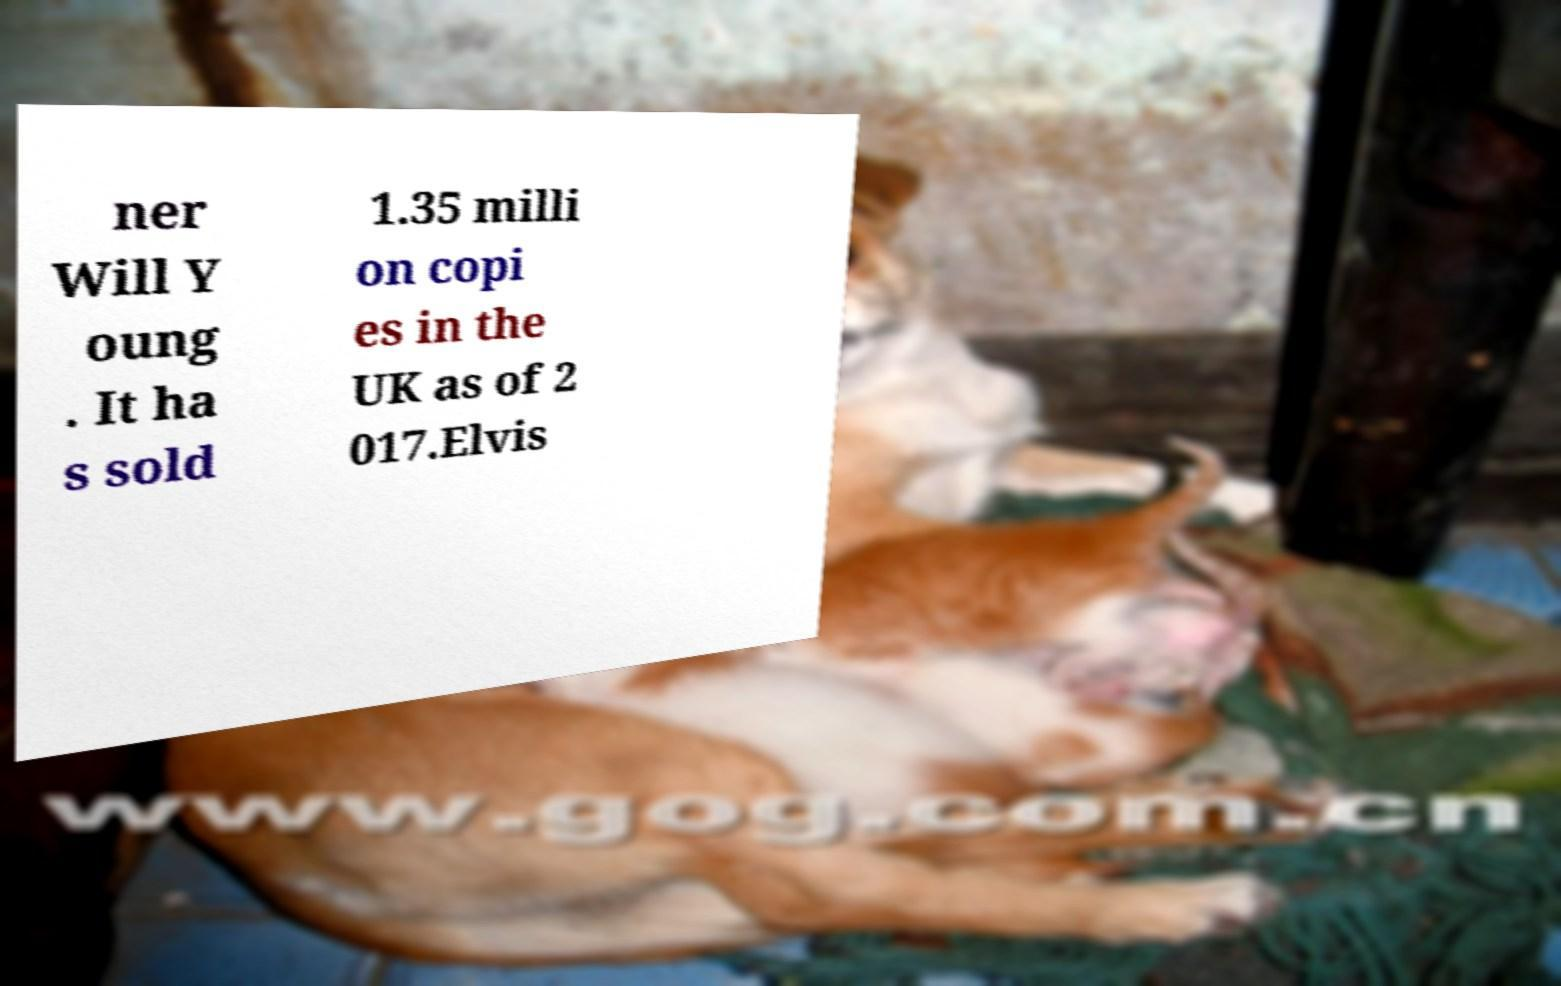For documentation purposes, I need the text within this image transcribed. Could you provide that? ner Will Y oung . It ha s sold 1.35 milli on copi es in the UK as of 2 017.Elvis 